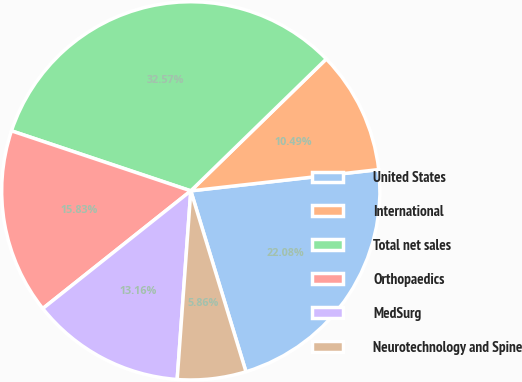Convert chart. <chart><loc_0><loc_0><loc_500><loc_500><pie_chart><fcel>United States<fcel>International<fcel>Total net sales<fcel>Orthopaedics<fcel>MedSurg<fcel>Neurotechnology and Spine<nl><fcel>22.08%<fcel>10.49%<fcel>32.57%<fcel>15.83%<fcel>13.16%<fcel>5.86%<nl></chart> 